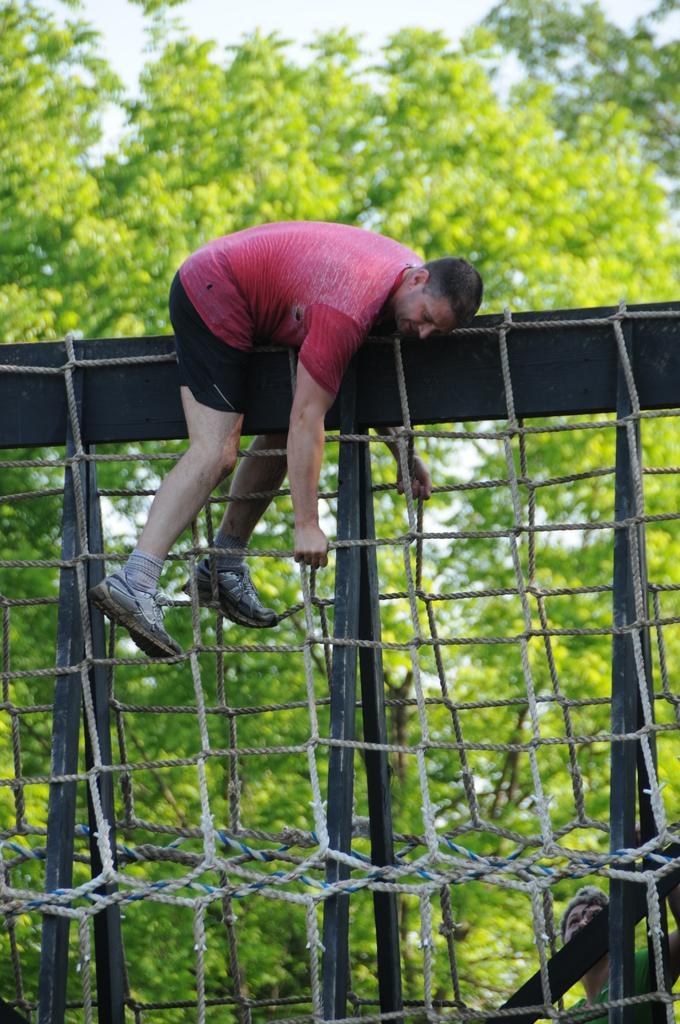In one or two sentences, can you explain what this image depicts? In this image, we can see a person on the stand. Here we can see ropes. Background there is a blur view. Here we can see trees and sky. At the bottom of the image, we can see another person. 